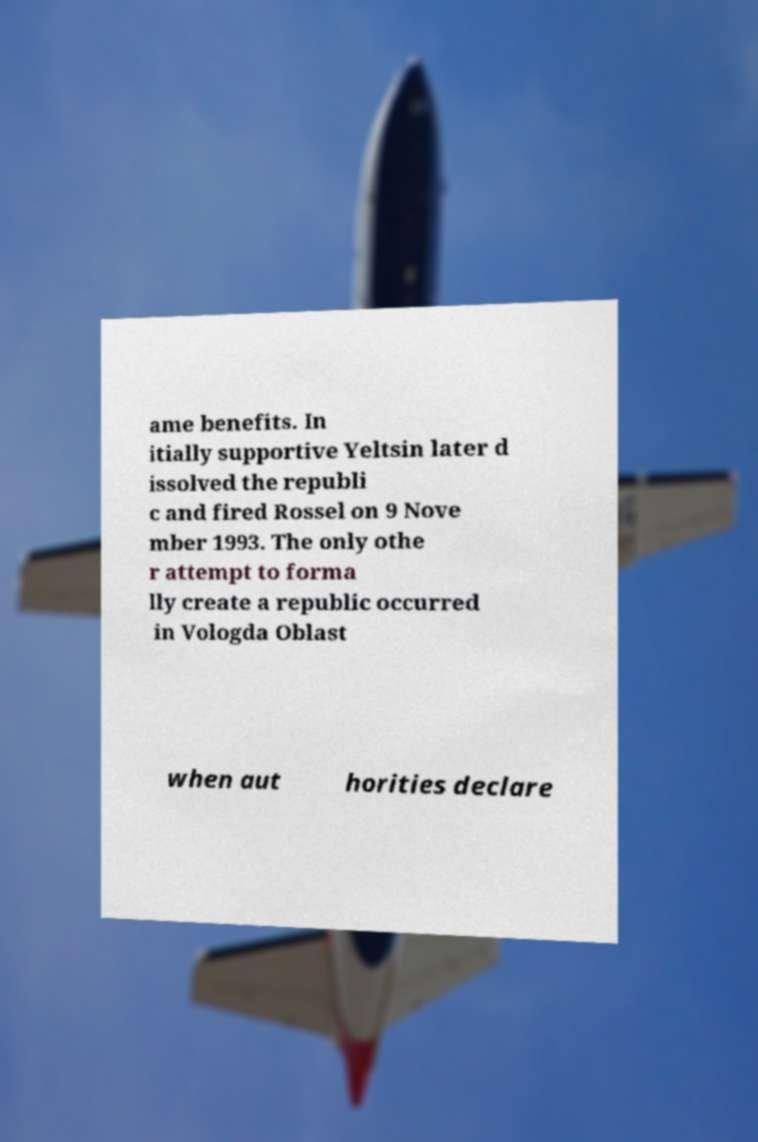Could you extract and type out the text from this image? ame benefits. In itially supportive Yeltsin later d issolved the republi c and fired Rossel on 9 Nove mber 1993. The only othe r attempt to forma lly create a republic occurred in Vologda Oblast when aut horities declare 